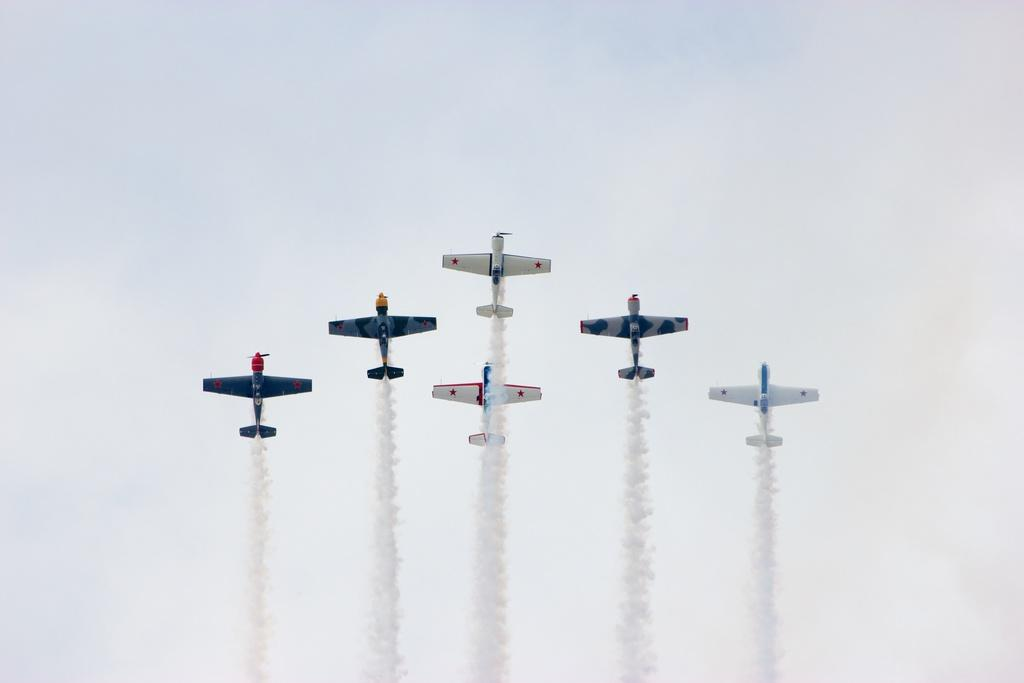What is the main subject of the image? The main subject of the image is planes. What environmental issue is depicted in the image? There is air pollution in the image. What can be seen in the sky in the background of the image? There are clouds visible in the sky in the background of the image. How many animals are present in the image? There are no animals present in the image. What type of parent is shown interacting with the planes in the image? There is no parent or interaction with planes depicted in the image. 